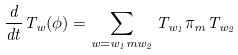<formula> <loc_0><loc_0><loc_500><loc_500>\frac { d } { d t } T _ { w } ( \phi ) = \sum _ { w = w _ { 1 } m w _ { 2 } } T _ { w _ { 1 } } \pi _ { m } T _ { w _ { 2 } }</formula> 